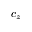<formula> <loc_0><loc_0><loc_500><loc_500>c _ { z }</formula> 